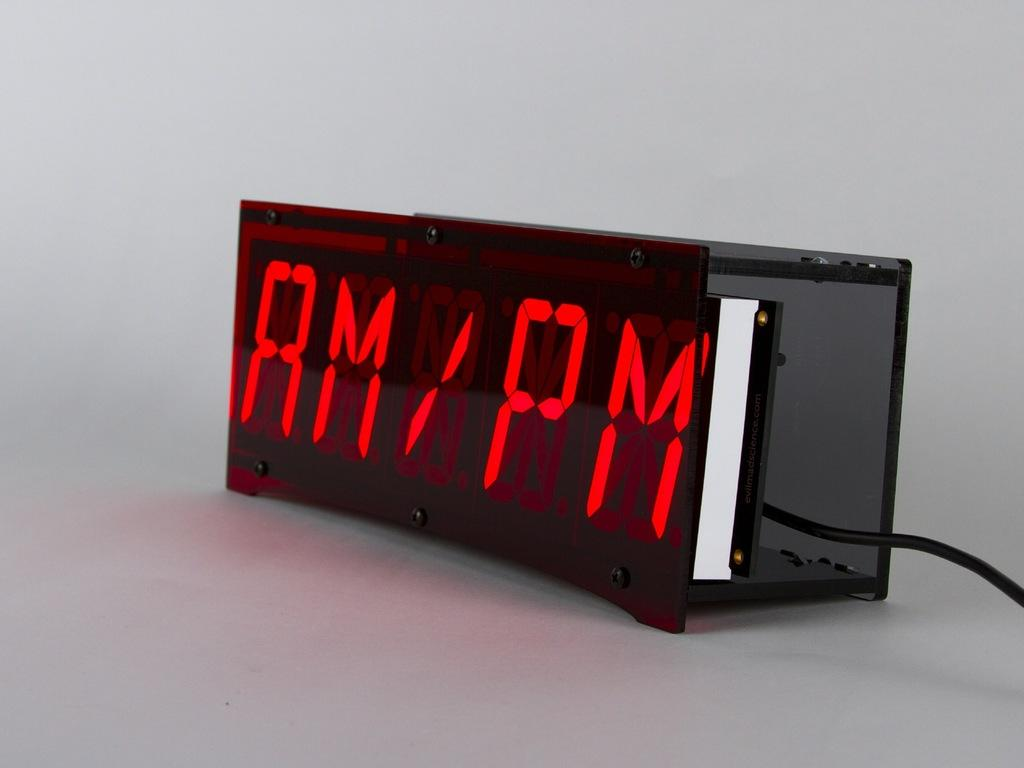<image>
Summarize the visual content of the image. A black digital clock is plugged in with AM/PM showing in red letters. 